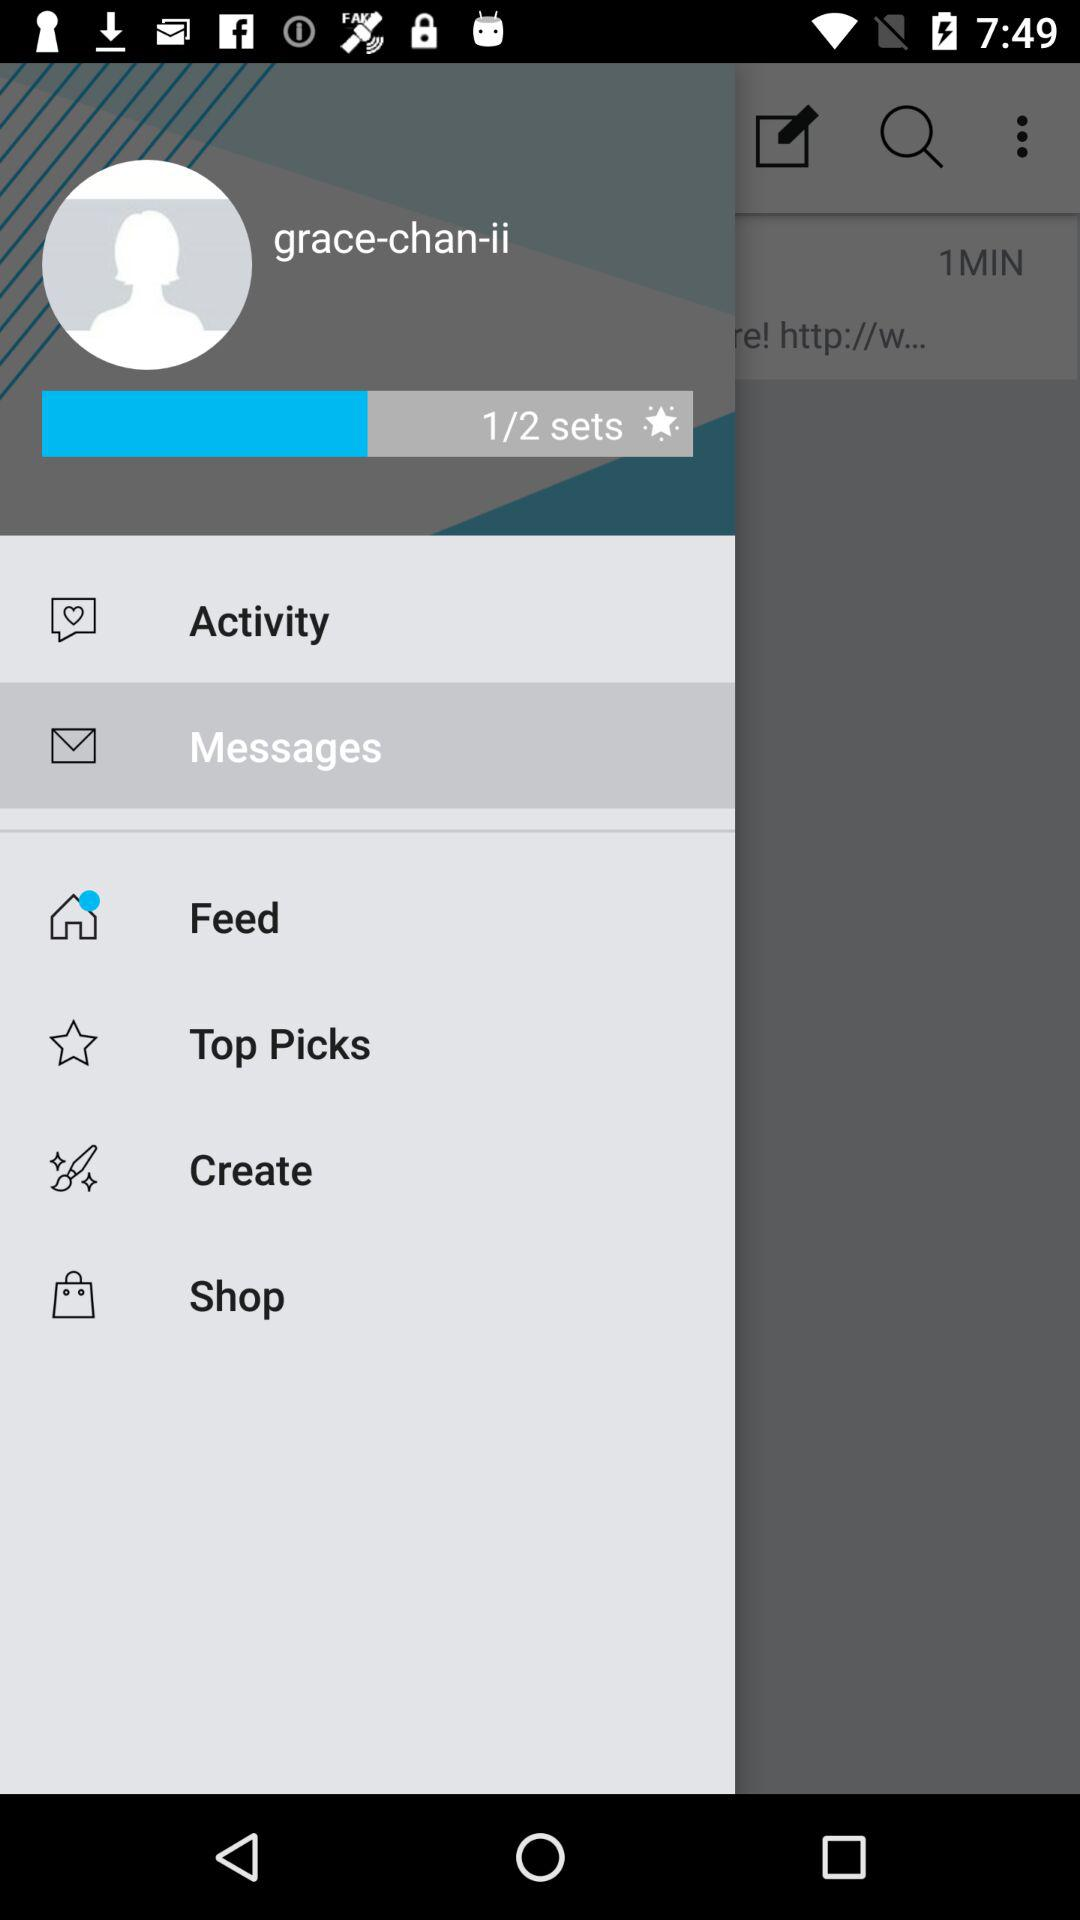What is the profile name? The profile name is "grace-chan-ii". 